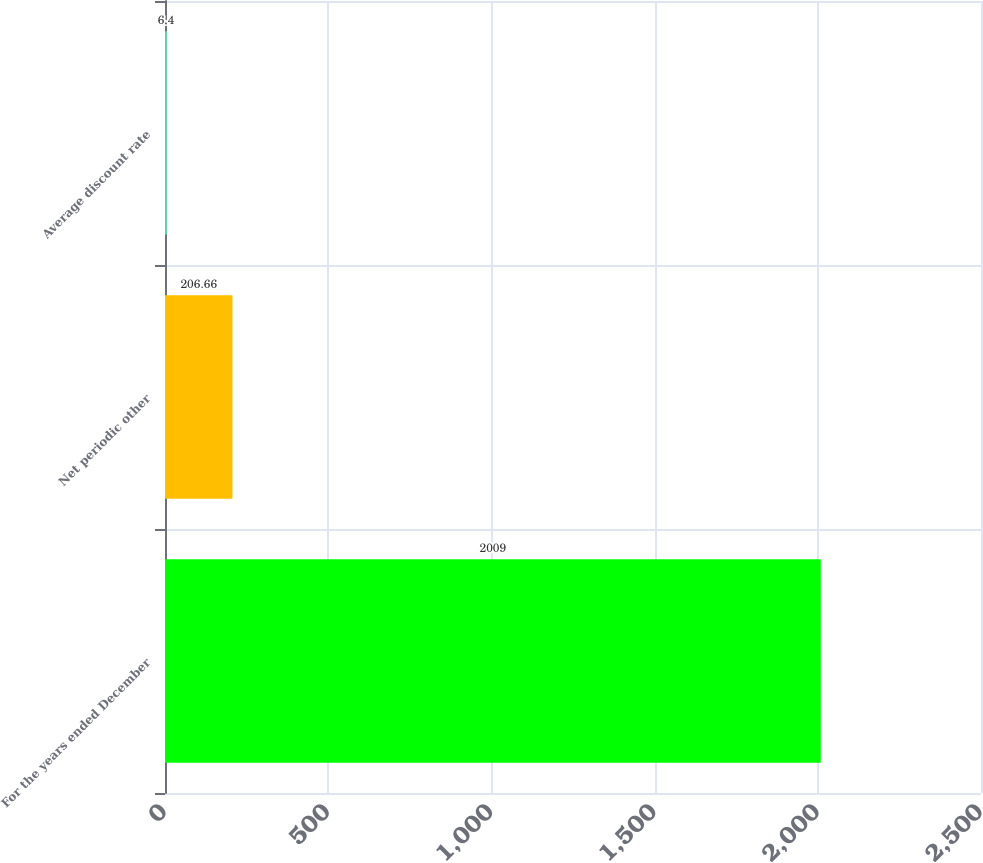Convert chart. <chart><loc_0><loc_0><loc_500><loc_500><bar_chart><fcel>For the years ended December<fcel>Net periodic other<fcel>Average discount rate<nl><fcel>2009<fcel>206.66<fcel>6.4<nl></chart> 